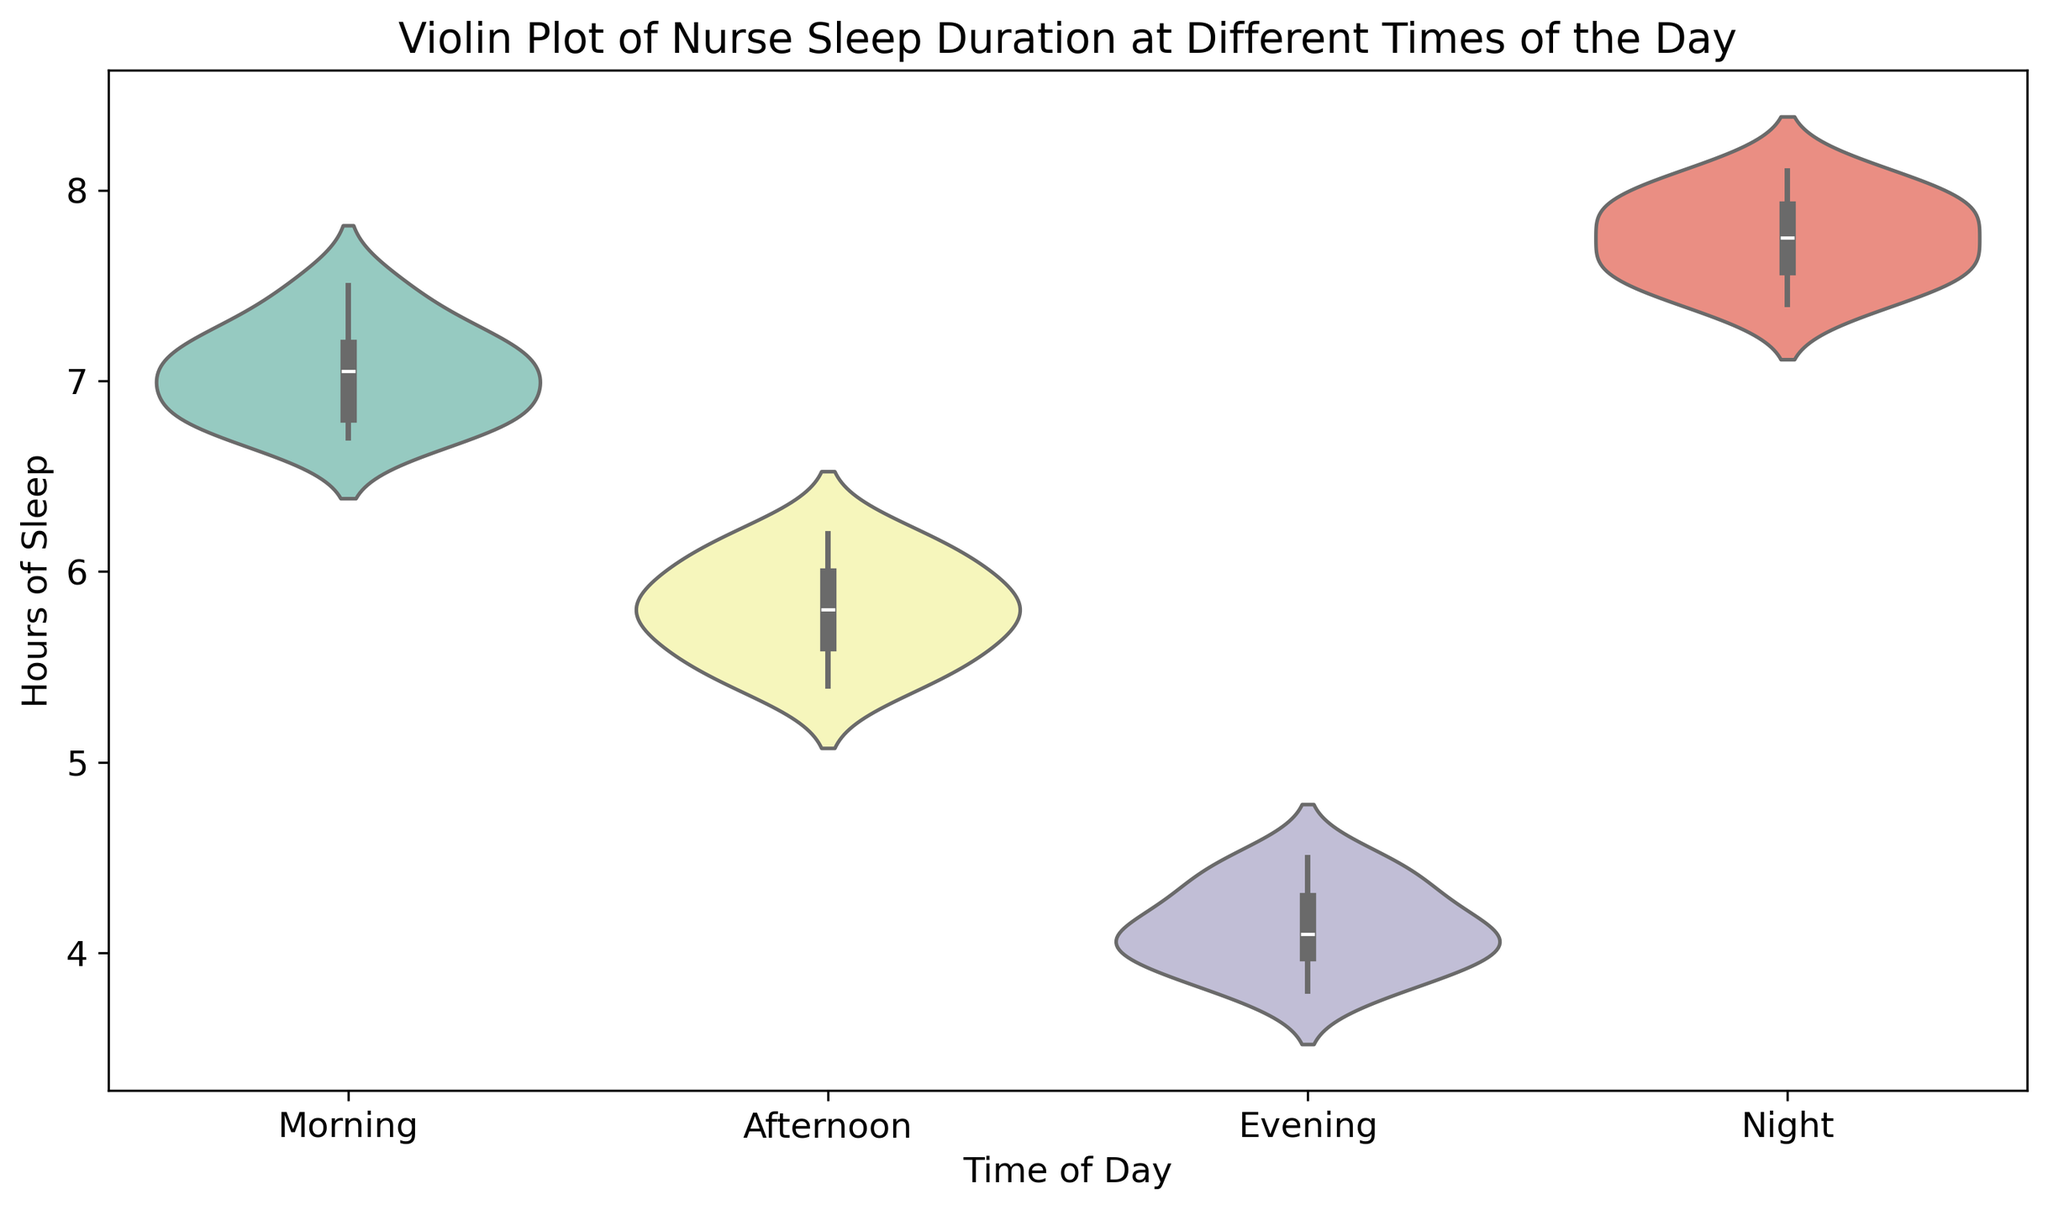What time of day has the highest median hours of sleep? To find the median hours of sleep for each time of day, look at the thickest part of the violin plot centered vertically. The night time slice has the highest median as it is the highest up on the vertical axis.
Answer: Night Which time of day shows the most variability in sleep duration? To determine variability, observe the spread of the violin plot for each time slice. Morning has a wide spread, indicating high variability in sleep duration.
Answer: Morning Compare the average hours of sleep in the afternoon and evening. Which is greater? By observing the central tendency and overall distribution from the plot, the afternoon slice is noticeably higher than the evening slice, suggesting the average hours of sleep is higher in the afternoon.
Answer: Afternoon What is the range of hours of sleep for the night time? The range is determined by the top and bottom extremes of the distribution. The night segment spans approximately from 7.4 to 8.1 hours.
Answer: 0.7 hours Is there any overlap in sleep hours between morning and afternoon? Overlap can be identified by examining whether the distributions of two slices intersect. The morning (around 6.7 to 7.5) and afternoon (around 5.4 to 6.2) distributions do not intersect, suggesting no direct overlap in these times of day.
Answer: No Which time of day shows the least amount of sleep duration? Identify the lowest median or range in the violin plot. The evening time has the lower end of the sleep duration, averaging around 4 hours.
Answer: Evening Consider the interquartile range (IQR) of hours of sleep for morning and night. Which has a larger IQR? The IQR is represented by the width of the violin in the middle 50%. Morning has a wider middle section than night, indicating a larger IQR.
Answer: Morning If the goal is to maximize the nurse's sleep, which time of day should be avoided? Based on the overall lower number of hours of sleep, the evening should be avoided as it consistently shows the least sleep duration.
Answer: Evening What is the mean sleep duration for the morning? Estimate the mean by considering the overall central tendency and distribution spread. The morning average is approximately around the midpoint of the plot, close to 7 hours.
Answer: 7 hours 